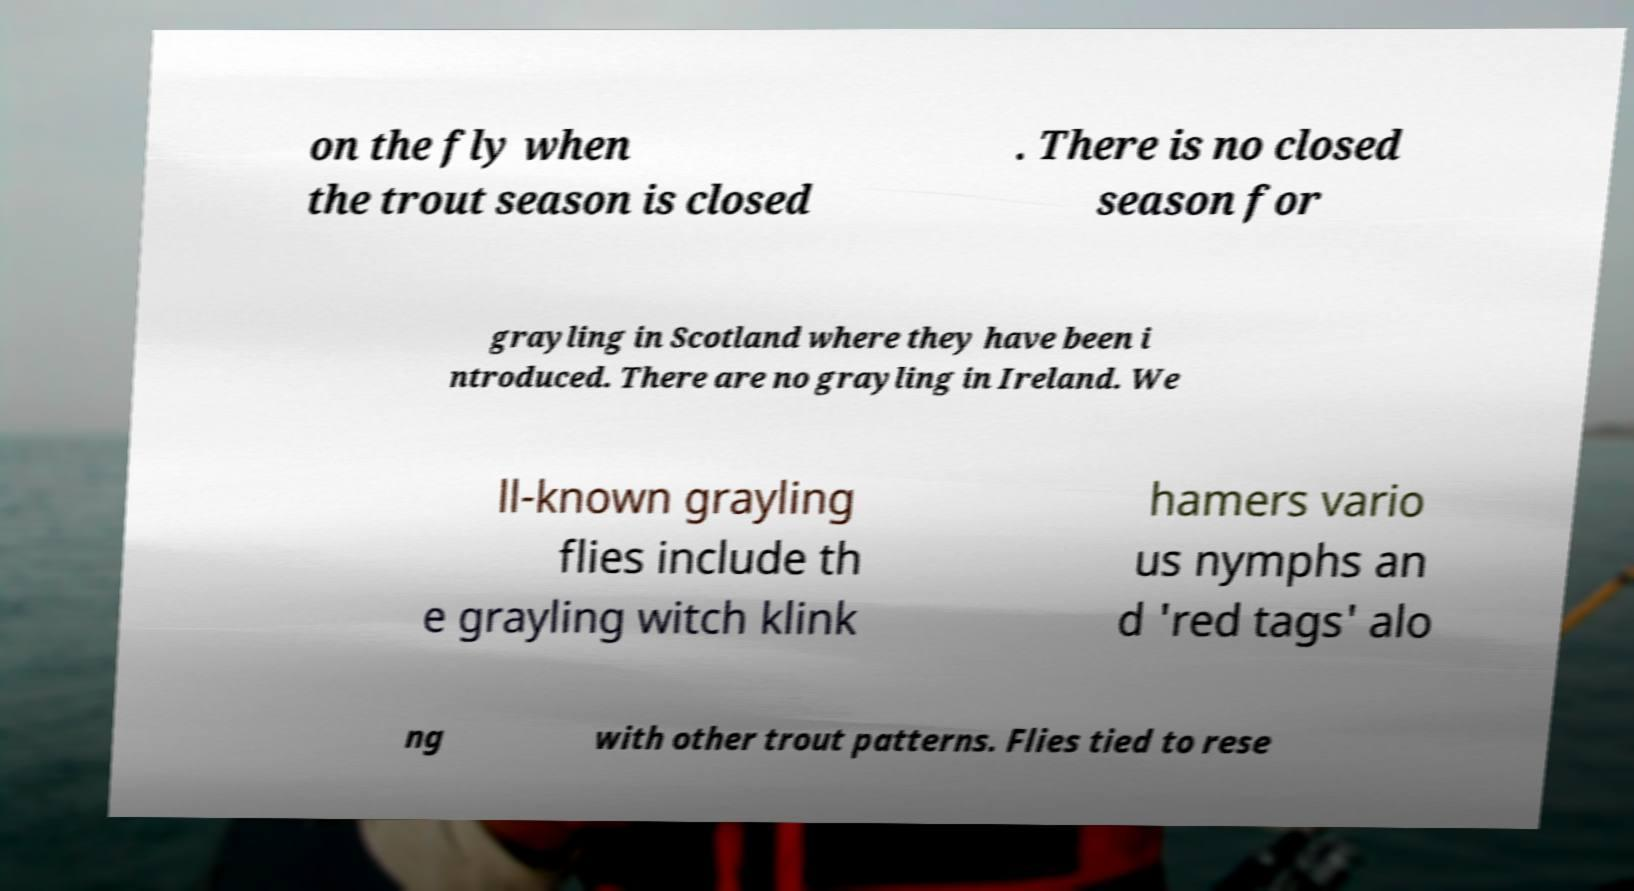Can you read and provide the text displayed in the image?This photo seems to have some interesting text. Can you extract and type it out for me? on the fly when the trout season is closed . There is no closed season for grayling in Scotland where they have been i ntroduced. There are no grayling in Ireland. We ll-known grayling flies include th e grayling witch klink hamers vario us nymphs an d 'red tags' alo ng with other trout patterns. Flies tied to rese 